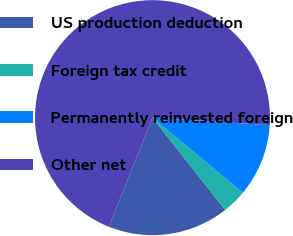Convert chart to OTSL. <chart><loc_0><loc_0><loc_500><loc_500><pie_chart><fcel>US production deduction<fcel>Foreign tax credit<fcel>Permanently reinvested foreign<fcel>Other net<nl><fcel>16.68%<fcel>3.35%<fcel>10.01%<fcel>69.96%<nl></chart> 